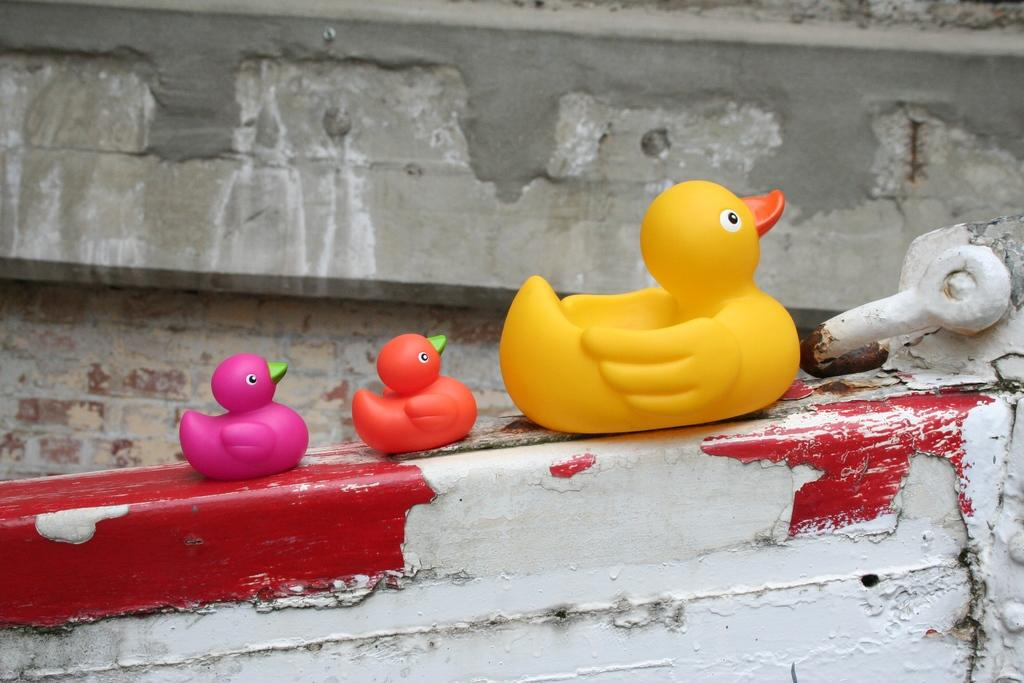What objects are in the middle of the image? There are three duck toys in the middle of the image. What are the duck toys placed on? The duck toys are on iron objects. What can be seen in the background of the image? There is a wall in the background of the image. What type of society is depicted in the image? There is no society depicted in the image; it features three duck toys on iron objects with a wall in the background. How does the acoustics of the room affect the sound of the duck toys in the image? The image does not provide any information about the acoustics of the room, so it cannot be determined how they might affect the sound of the duck toys. 